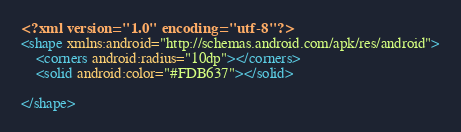<code> <loc_0><loc_0><loc_500><loc_500><_XML_><?xml version="1.0" encoding="utf-8"?>
<shape xmlns:android="http://schemas.android.com/apk/res/android">
    <corners android:radius="10dp"></corners>
    <solid android:color="#FDB637"></solid>

</shape></code> 